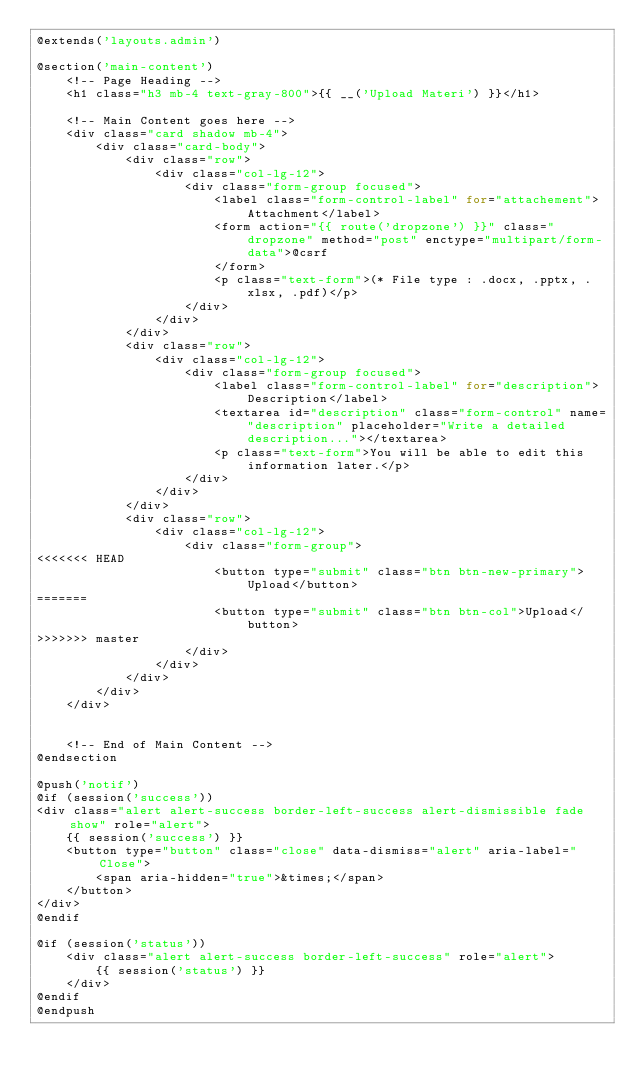Convert code to text. <code><loc_0><loc_0><loc_500><loc_500><_PHP_>@extends('layouts.admin')

@section('main-content')
    <!-- Page Heading -->
    <h1 class="h3 mb-4 text-gray-800">{{ __('Upload Materi') }}</h1>

    <!-- Main Content goes here -->
    <div class="card shadow mb-4">
        <div class="card-body">
            <div class="row">
                <div class="col-lg-12">
                    <div class="form-group focused">
                        <label class="form-control-label" for="attachement">Attachment</label>
                        <form action="{{ route('dropzone') }}" class="dropzone" method="post" enctype="multipart/form-data">@csrf
                        </form>
                        <p class="text-form">(* File type : .docx, .pptx, .xlsx, .pdf)</p>
                    </div>
                </div>
            </div>
            <div class="row">
                <div class="col-lg-12">
                    <div class="form-group focused">
                        <label class="form-control-label" for="description">Description</label>
                        <textarea id="description" class="form-control" name="description" placeholder="Write a detailed description..."></textarea>
                        <p class="text-form">You will be able to edit this information later.</p>
                    </div>
                </div>
            </div>
            <div class="row">
                <div class="col-lg-12">
                    <div class="form-group">
<<<<<<< HEAD
                        <button type="submit" class="btn btn-new-primary">Upload</button>
=======
                        <button type="submit" class="btn btn-col">Upload</button>
>>>>>>> master
                    </div>
                </div>
            </div>
        </div>
    </div>


    <!-- End of Main Content -->
@endsection

@push('notif')
@if (session('success'))
<div class="alert alert-success border-left-success alert-dismissible fade show" role="alert">
    {{ session('success') }}
    <button type="button" class="close" data-dismiss="alert" aria-label="Close">
        <span aria-hidden="true">&times;</span>
    </button>
</div>
@endif

@if (session('status'))
    <div class="alert alert-success border-left-success" role="alert">
        {{ session('status') }}
    </div>
@endif
@endpush
</code> 